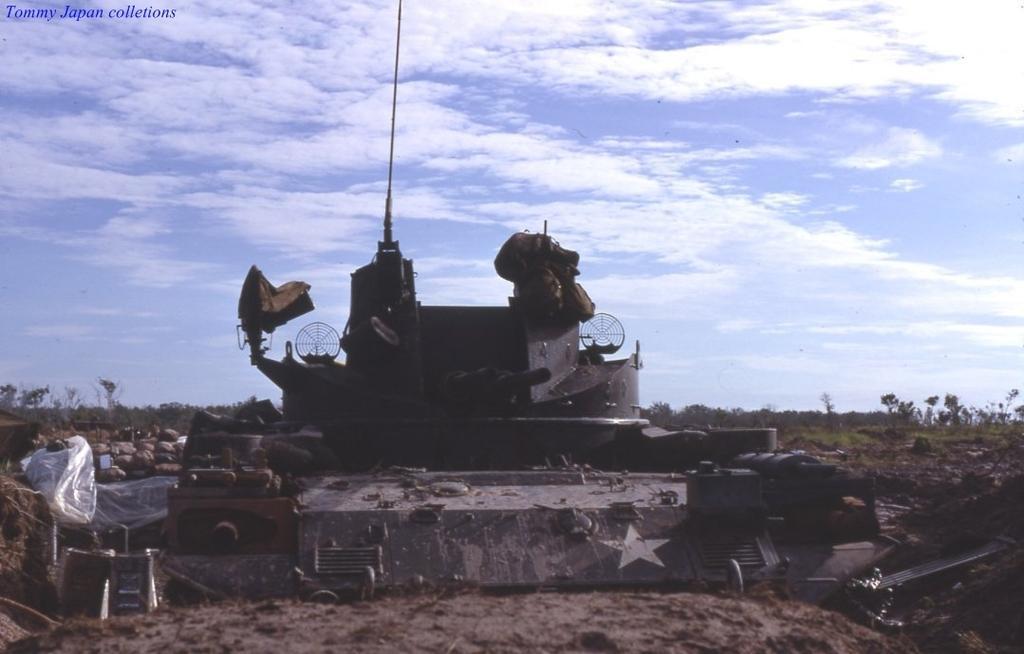Can you describe this image briefly? This image consists of panzer tank kept on the ground. At the bottom, there is ground. To the left, there are rocks. In the background, there are trees and plants. To the top, there are clouds in the sky. 